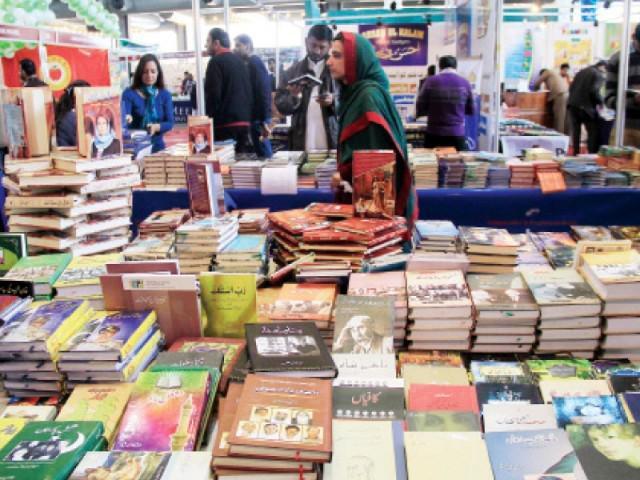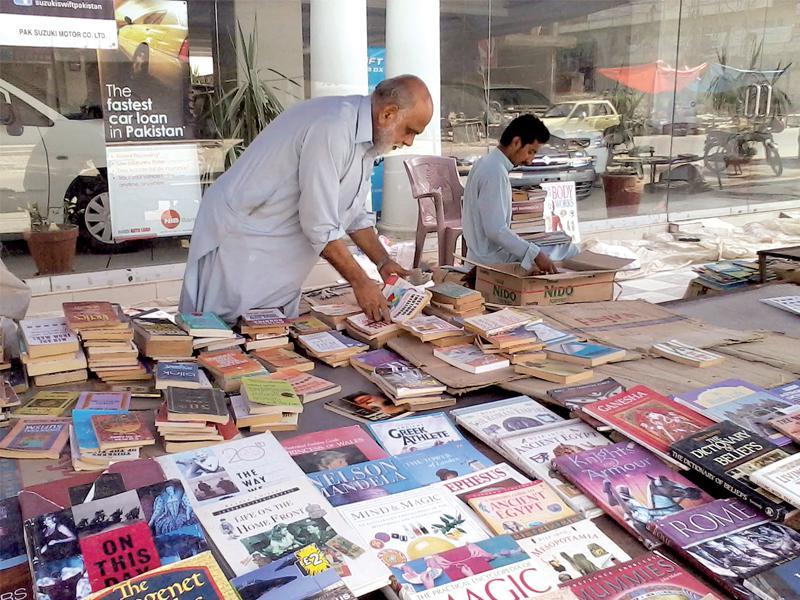The first image is the image on the left, the second image is the image on the right. Considering the images on both sides, is "There are products on the asphalt road in both images." valid? Answer yes or no. No. The first image is the image on the left, the second image is the image on the right. Given the left and right images, does the statement "One woman is wearing a hijab while shopping for books." hold true? Answer yes or no. Yes. 